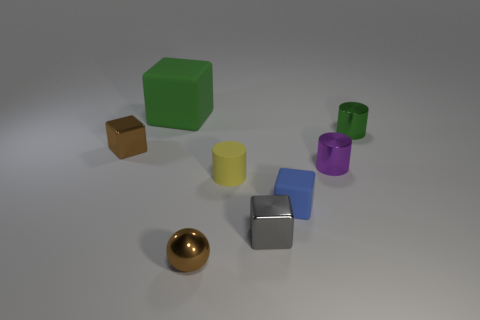Can you tell me about the reflective qualities of the objects in the image? Certainly! The objects in the image display a variety of reflective qualities. The sphere and the two cubes at the foreground have a high level of reflectivity, indicating that they are likely made of polished metals. The rest of the objects, which are of different colors, seem to have a matte finish, suggesting that those could be made of a non-metallic material like plastic, which absorbs more light and is less reflective. 